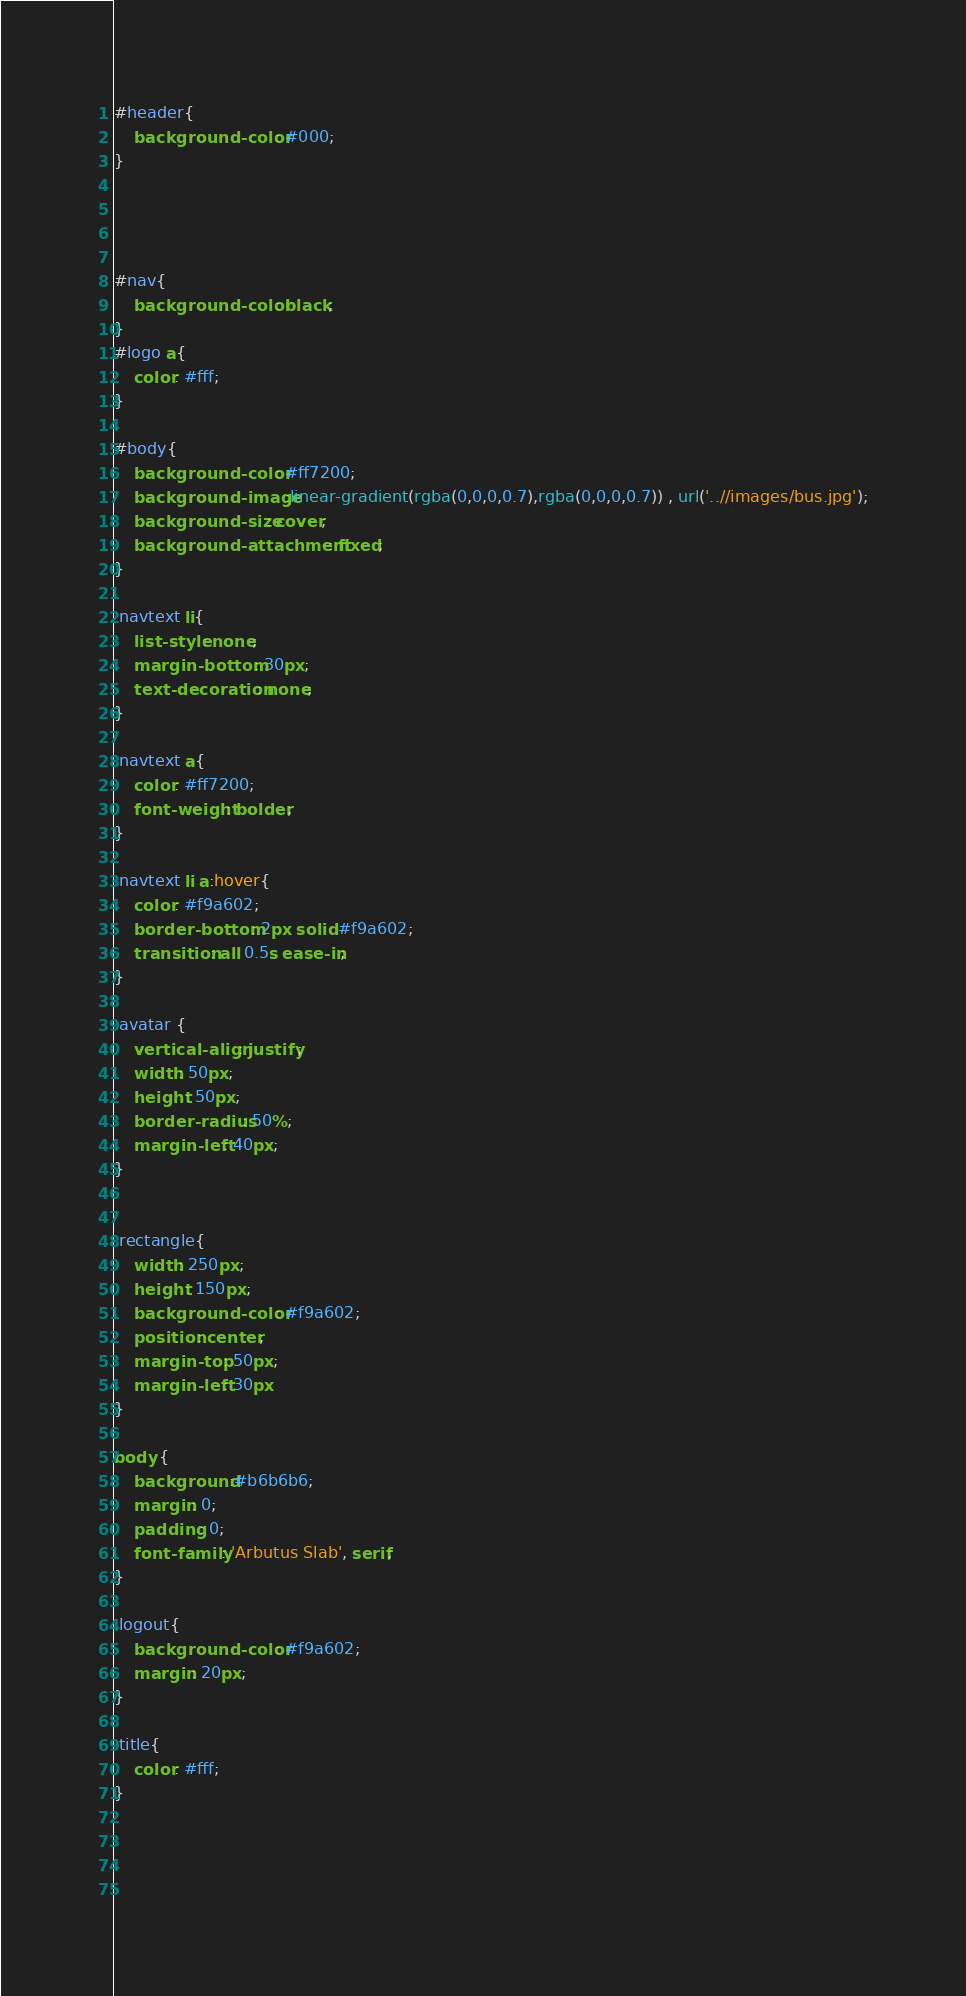<code> <loc_0><loc_0><loc_500><loc_500><_CSS_>#header{
	background-color: #000;
}




#nav{
	background-color: black;
}
#logo a{
	color: #fff;
}

#body{
	background-color: #ff7200;
	background-image:linear-gradient(rgba(0,0,0,0.7),rgba(0,0,0,0.7)) , url('..//images/bus.jpg');
	background-size: cover;
	background-attachment: fixed;
}

.navtext li{
	list-style: none;
	margin-bottom: 30px;
	text-decoration: none;
}

.navtext a{
	color: #ff7200;
	font-weight: bolder;
}

.navtext li a:hover{
	color: #f9a602;
	border-bottom: 2px solid #f9a602;
	transition: all 0.5s ease-in;
}

.avatar {
    vertical-align: justify;
    width: 50px;
    height: 50px;
    border-radius: 50%;
    margin-left: 40px;
}


.rectangle{
	width: 250px;
	height: 150px;
	background-color: #f9a602;
	position: center;
	margin-top: 50px;
	margin-left: 30px
}

body {
	background:#b6b6b6;
	margin: 0;
	padding: 0;
	font-family: 'Arbutus Slab', serif;
}

.logout{
	background-color: #f9a602;
	margin: 20px;
}

.title{
	color: #fff;
}


   
    </code> 